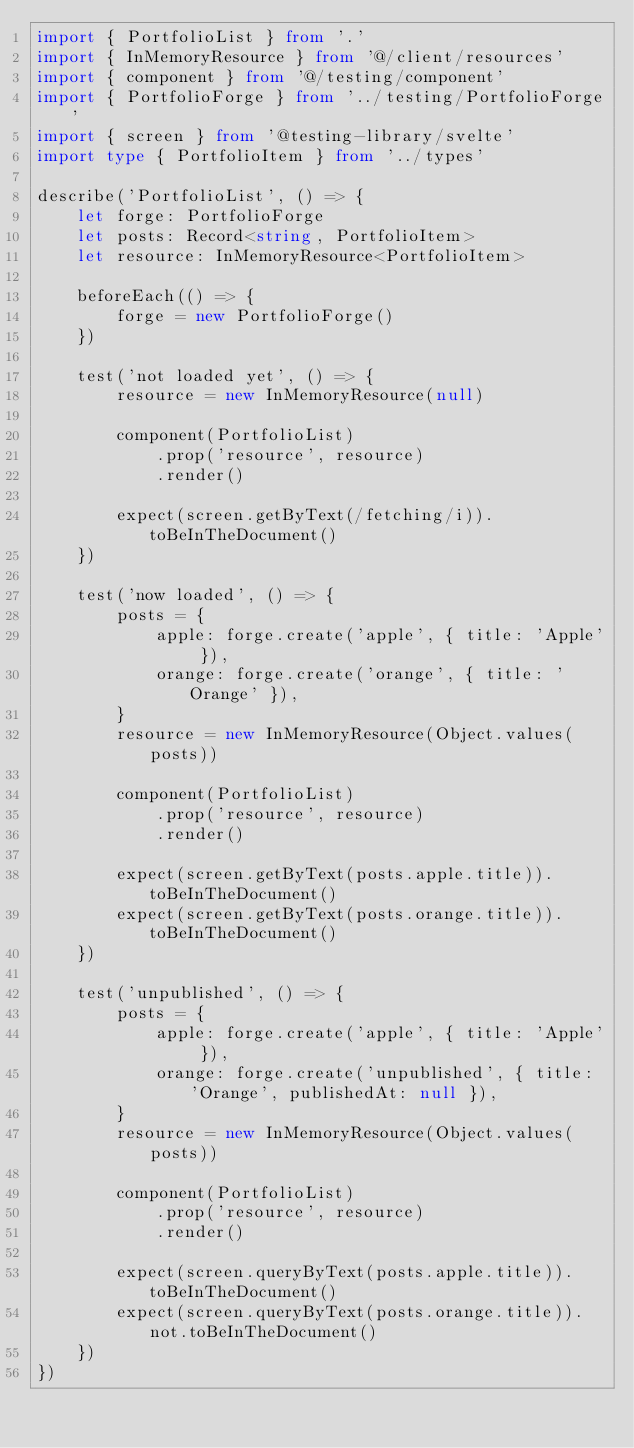Convert code to text. <code><loc_0><loc_0><loc_500><loc_500><_TypeScript_>import { PortfolioList } from '.'
import { InMemoryResource } from '@/client/resources'
import { component } from '@/testing/component'
import { PortfolioForge } from '../testing/PortfolioForge'
import { screen } from '@testing-library/svelte'
import type { PortfolioItem } from '../types'

describe('PortfolioList', () => {
    let forge: PortfolioForge
    let posts: Record<string, PortfolioItem>
    let resource: InMemoryResource<PortfolioItem>

    beforeEach(() => {
        forge = new PortfolioForge()
    })

    test('not loaded yet', () => {
        resource = new InMemoryResource(null)

        component(PortfolioList)
            .prop('resource', resource)
            .render()

        expect(screen.getByText(/fetching/i)).toBeInTheDocument()
    })

    test('now loaded', () => {
        posts = {
            apple: forge.create('apple', { title: 'Apple' }),
            orange: forge.create('orange', { title: 'Orange' }),
        }
        resource = new InMemoryResource(Object.values(posts))

        component(PortfolioList)
            .prop('resource', resource)
            .render()

        expect(screen.getByText(posts.apple.title)).toBeInTheDocument()
        expect(screen.getByText(posts.orange.title)).toBeInTheDocument()
    })

    test('unpublished', () => {
        posts = {
            apple: forge.create('apple', { title: 'Apple' }),
            orange: forge.create('unpublished', { title: 'Orange', publishedAt: null }),
        }
        resource = new InMemoryResource(Object.values(posts))

        component(PortfolioList)
            .prop('resource', resource)
            .render()

        expect(screen.queryByText(posts.apple.title)).toBeInTheDocument()
        expect(screen.queryByText(posts.orange.title)).not.toBeInTheDocument()
    })
})
</code> 